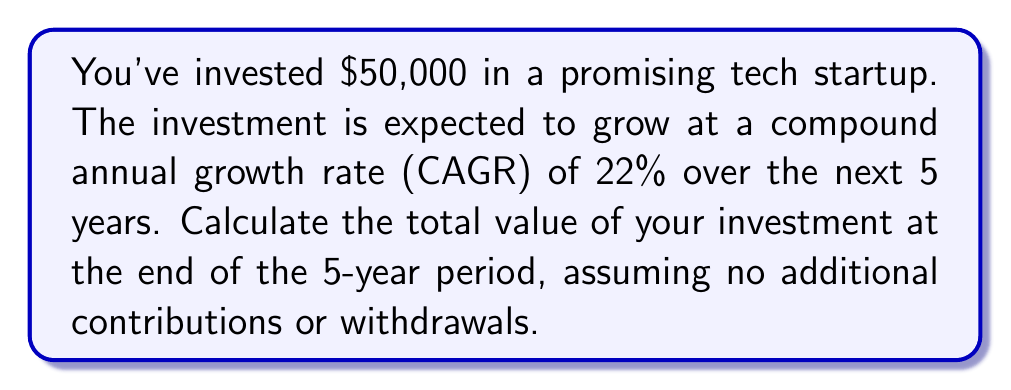Could you help me with this problem? To solve this problem, we'll use the compound interest formula:

$$A = P(1 + r)^t$$

Where:
$A$ = Final amount
$P$ = Principal (initial investment)
$r$ = Annual interest rate (as a decimal)
$t$ = Time period (in years)

Given:
$P = \$50,000$
$r = 22\% = 0.22$
$t = 5$ years

Step 1: Plug the values into the formula
$$A = 50,000(1 + 0.22)^5$$

Step 2: Calculate the value inside the parentheses
$$A = 50,000(1.22)^5$$

Step 3: Calculate the exponent
$$A = 50,000(2.7149)$$

Step 4: Multiply
$$A = 135,745$$

Therefore, the total value of your investment after 5 years will be $135,745.
Answer: $135,745 